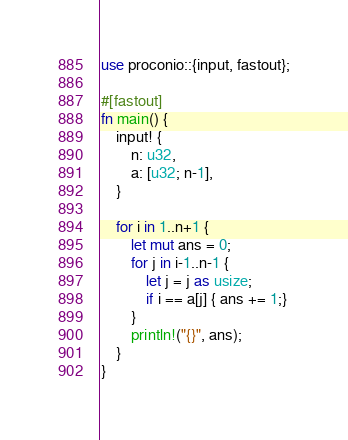Convert code to text. <code><loc_0><loc_0><loc_500><loc_500><_Rust_>use proconio::{input, fastout};

#[fastout]
fn main() {
    input! {
        n: u32,
        a: [u32; n-1],
    }

    for i in 1..n+1 {
        let mut ans = 0;
        for j in i-1..n-1 {
            let j = j as usize;
            if i == a[j] { ans += 1;}
        }
        println!("{}", ans);
    }
}
</code> 